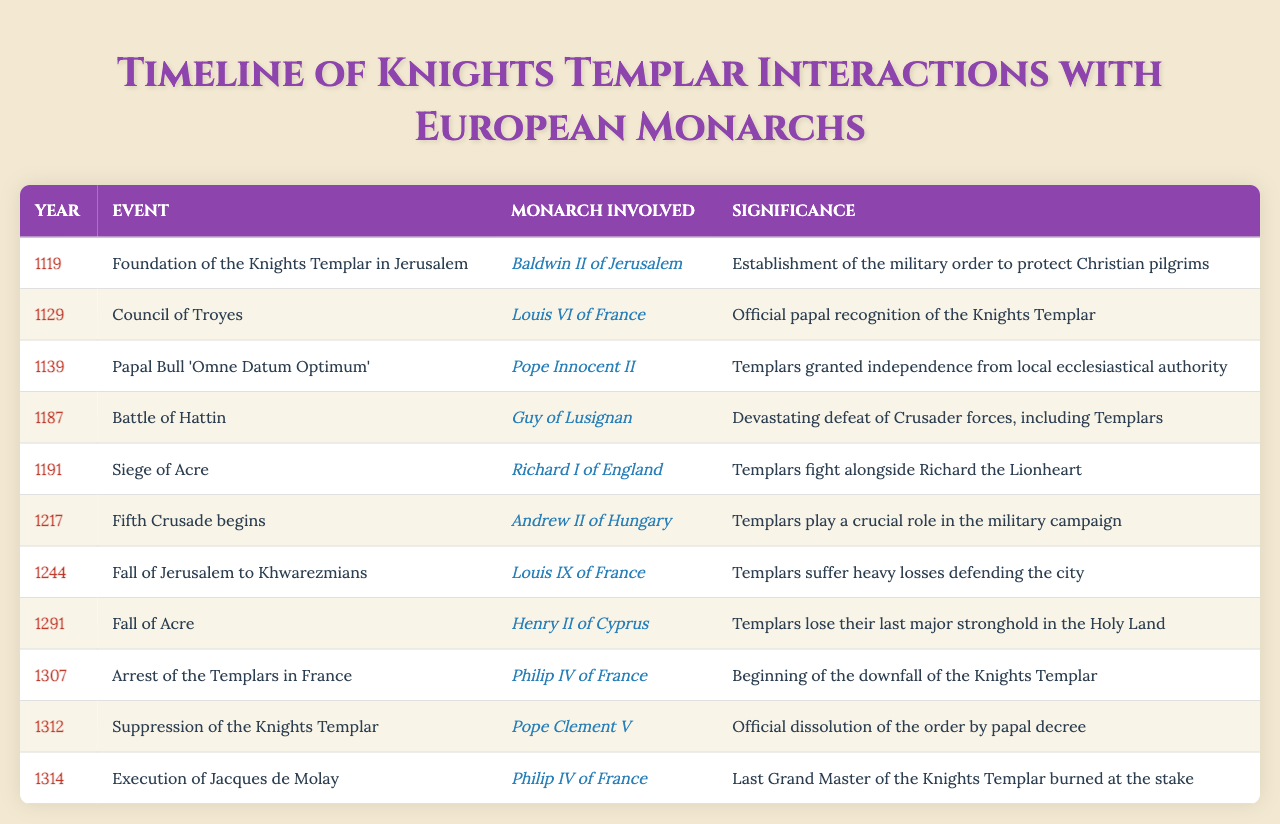What year was the Council of Troyes held? The table lists the event "Council of Troyes" as occurring in the year 1129.
Answer: 1129 Who was the monarch involved in the Siege of Acre? The table indicates that Richard I of England was the monarch involved in the Siege of Acre in the year 1191.
Answer: Richard I of England How many events involved Philip IV of France? By counting the occurrences of "Philip IV of France" in the table, we find it appears twice - for the arrest of the Templars in 1307 and the execution of Jacques de Molay in 1314.
Answer: 2 What was the significance of the Fall of Acre in 1291? The table notes the significance of the Fall of Acre as the loss of the Templars' last major stronghold in the Holy Land.
Answer: Loss of last stronghold Which monarch was involved in both the execution of Jacques de Molay and the arrest of the Templars? Both events are linked to Philip IV of France, according to the table.
Answer: Philip IV of France Was the Papal Bull 'Omne Datum Optimum' issued in the 12th century? The date of the event is 1139, which is indeed in the 12th century; hence this statement is true.
Answer: Yes What event occurred immediately before the Fifth Crusade began? The Fall of Jerusalem to Khwarezmians in 1244 took place immediately before the Fifth Crusade, which began in 1217.
Answer: Fall of Jerusalem to Khwarezmians How did the arrest of the Templars in 1307 contribute to their downfall? The table highlights that the arrest marked the beginning of the downfall of the Knights Templar, indicating a critical downturn in their status and operations.
Answer: Beginning of downfall Which monarch was involved in the most events listed in the table? By analyzing the table, Philip IV of France appears in two events, while other monarchs like Louis IX also have two, making it difficult to pinpoint a single monarch as most involved, but two each is the highest count.
Answer: Several tied What was the significance of the Battle of Hattin in 1187? The table states that it was a devastating defeat for Crusader forces, including the Templars, illustrating its critical impact on that era.
Answer: Devastating defeat In what year did Pope Clement V officially dissolve the Knights Templar? The table shows that Pope Clement V suppressed the Knights Templar in 1312, marking the official dissolution.
Answer: 1312 